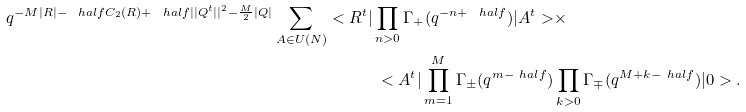Convert formula to latex. <formula><loc_0><loc_0><loc_500><loc_500>q ^ { - M | R | - \ h a l f C _ { 2 } ( R ) + \ h a l f | | Q ^ { t } | | ^ { 2 } - \frac { M } { 2 } | Q | } \sum _ { A \in U ( N ) } < R ^ { t } | \prod _ { n > 0 } \Gamma _ { + } ( q ^ { - n + \ h a l f } ) | A ^ { t } > & \times \\ < A ^ { t } | \prod _ { m = 1 } ^ { M } \Gamma _ { \pm } ( q ^ { m - \ h a l f } ) & \prod _ { k > 0 } \Gamma _ { \mp } ( q ^ { M + k - \ h a l f } ) | 0 > .</formula> 